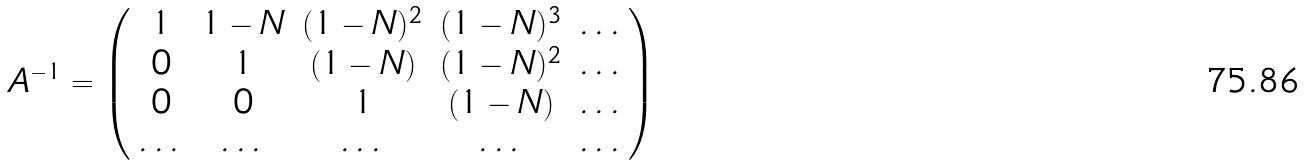Convert formula to latex. <formula><loc_0><loc_0><loc_500><loc_500>A ^ { - 1 } = \left ( \begin{array} { c c c c c } 1 & 1 - N & ( 1 - N ) ^ { 2 } & ( 1 - N ) ^ { 3 } & \dots \\ 0 & 1 & ( 1 - N ) & ( 1 - N ) ^ { 2 } & \dots \\ 0 & 0 & 1 & ( 1 - N ) & \dots \\ \dots & \dots & \dots & \dots & \dots \end{array} \right )</formula> 